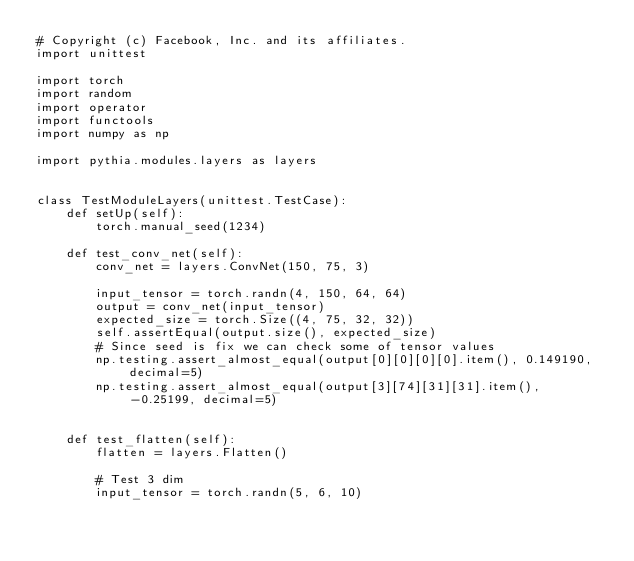<code> <loc_0><loc_0><loc_500><loc_500><_Python_># Copyright (c) Facebook, Inc. and its affiliates.
import unittest

import torch
import random
import operator
import functools
import numpy as np

import pythia.modules.layers as layers


class TestModuleLayers(unittest.TestCase):
    def setUp(self):
        torch.manual_seed(1234)

    def test_conv_net(self):
        conv_net = layers.ConvNet(150, 75, 3)

        input_tensor = torch.randn(4, 150, 64, 64)
        output = conv_net(input_tensor)
        expected_size = torch.Size((4, 75, 32, 32))
        self.assertEqual(output.size(), expected_size)
        # Since seed is fix we can check some of tensor values
        np.testing.assert_almost_equal(output[0][0][0][0].item(), 0.149190, decimal=5)
        np.testing.assert_almost_equal(output[3][74][31][31].item(), -0.25199, decimal=5)


    def test_flatten(self):
        flatten = layers.Flatten()

        # Test 3 dim
        input_tensor = torch.randn(5, 6, 10)</code> 